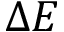Convert formula to latex. <formula><loc_0><loc_0><loc_500><loc_500>\Delta E</formula> 